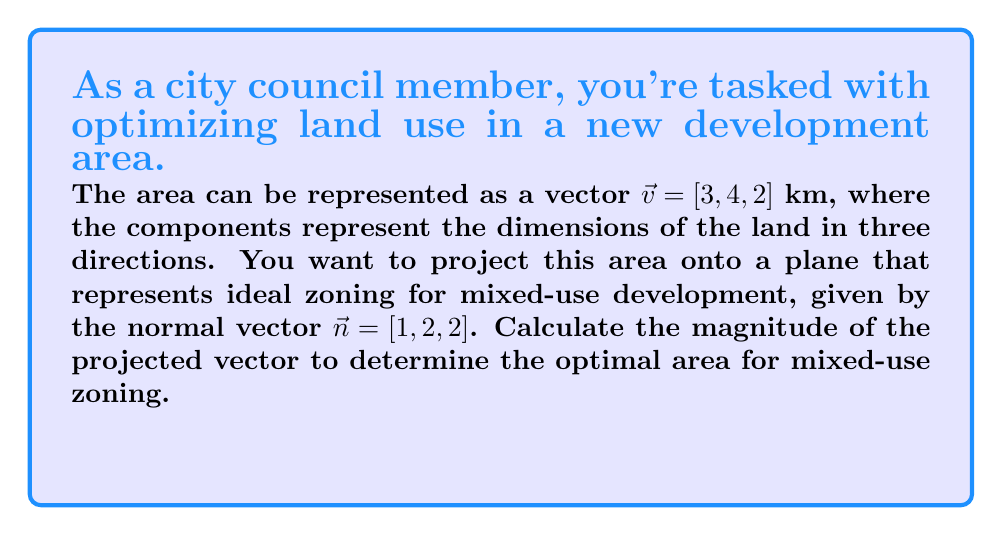Help me with this question. Let's approach this step-by-step:

1) The formula for vector projection of $\vec{v}$ onto the plane with normal $\vec{n}$ is:

   $$\vec{v}_{\text{proj}} = \vec{v} - \frac{\vec{v} \cdot \vec{n}}{\|\vec{n}\|^2} \vec{n}$$

2) First, calculate the dot product $\vec{v} \cdot \vec{n}$:
   $$\vec{v} \cdot \vec{n} = 3(1) + 4(2) + 2(2) = 3 + 8 + 4 = 15$$

3) Next, calculate $\|\vec{n}\|^2$:
   $$\|\vec{n}\|^2 = 1^2 + 2^2 + 2^2 = 1 + 4 + 4 = 9$$

4) Now we can calculate $\frac{\vec{v} \cdot \vec{n}}{\|\vec{n}\|^2}$:
   $$\frac{\vec{v} \cdot \vec{n}}{\|\vec{n}\|^2} = \frac{15}{9} = \frac{5}{3}$$

5) Multiply this scalar by $\vec{n}$:
   $$\frac{5}{3} \vec{n} = [\frac{5}{3}, \frac{10}{3}, \frac{10}{3}]$$

6) Subtract this from $\vec{v}$:
   $$\vec{v}_{\text{proj}} = [3, 4, 2] - [\frac{5}{3}, \frac{10}{3}, \frac{10}{3}] = [\frac{4}{3}, \frac{2}{3}, -\frac{4}{3}]$$

7) To find the magnitude of this projected vector:
   $$\|\vec{v}_{\text{proj}}\| = \sqrt{(\frac{4}{3})^2 + (\frac{2}{3})^2 + (-\frac{4}{3})^2}$$
   $$= \sqrt{\frac{16}{9} + \frac{4}{9} + \frac{16}{9}} = \sqrt{\frac{36}{9}} = 2$$

Therefore, the magnitude of the projected vector is 2 km.
Answer: 2 km 